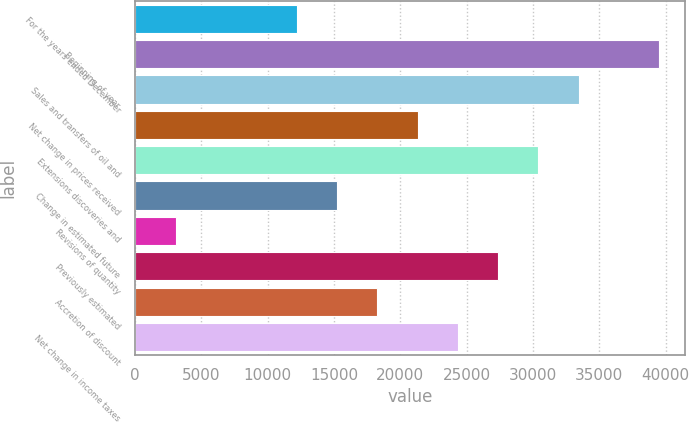Convert chart. <chart><loc_0><loc_0><loc_500><loc_500><bar_chart><fcel>For the years ended December<fcel>Beginning of year<fcel>Sales and transfers of oil and<fcel>Net change in prices received<fcel>Extensions discoveries and<fcel>Change in estimated future<fcel>Revisions of quantity<fcel>Previously estimated<fcel>Accretion of discount<fcel>Net change in income taxes<nl><fcel>12191.8<fcel>39522.1<fcel>33448.7<fcel>21301.9<fcel>30412<fcel>15228.5<fcel>3081.7<fcel>27375.3<fcel>18265.2<fcel>24338.6<nl></chart> 